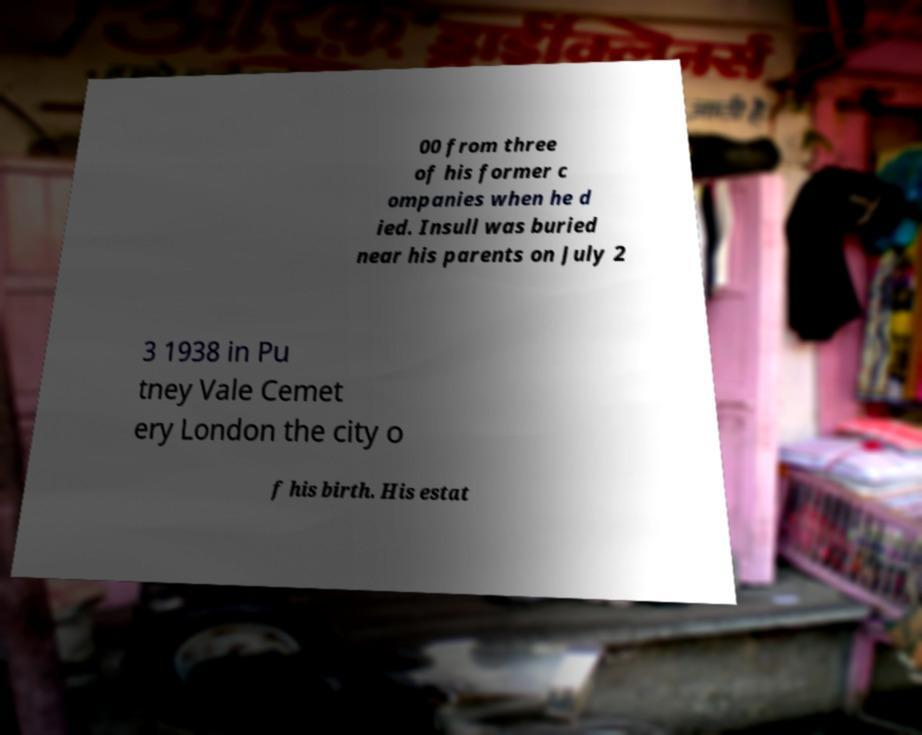Could you extract and type out the text from this image? 00 from three of his former c ompanies when he d ied. Insull was buried near his parents on July 2 3 1938 in Pu tney Vale Cemet ery London the city o f his birth. His estat 